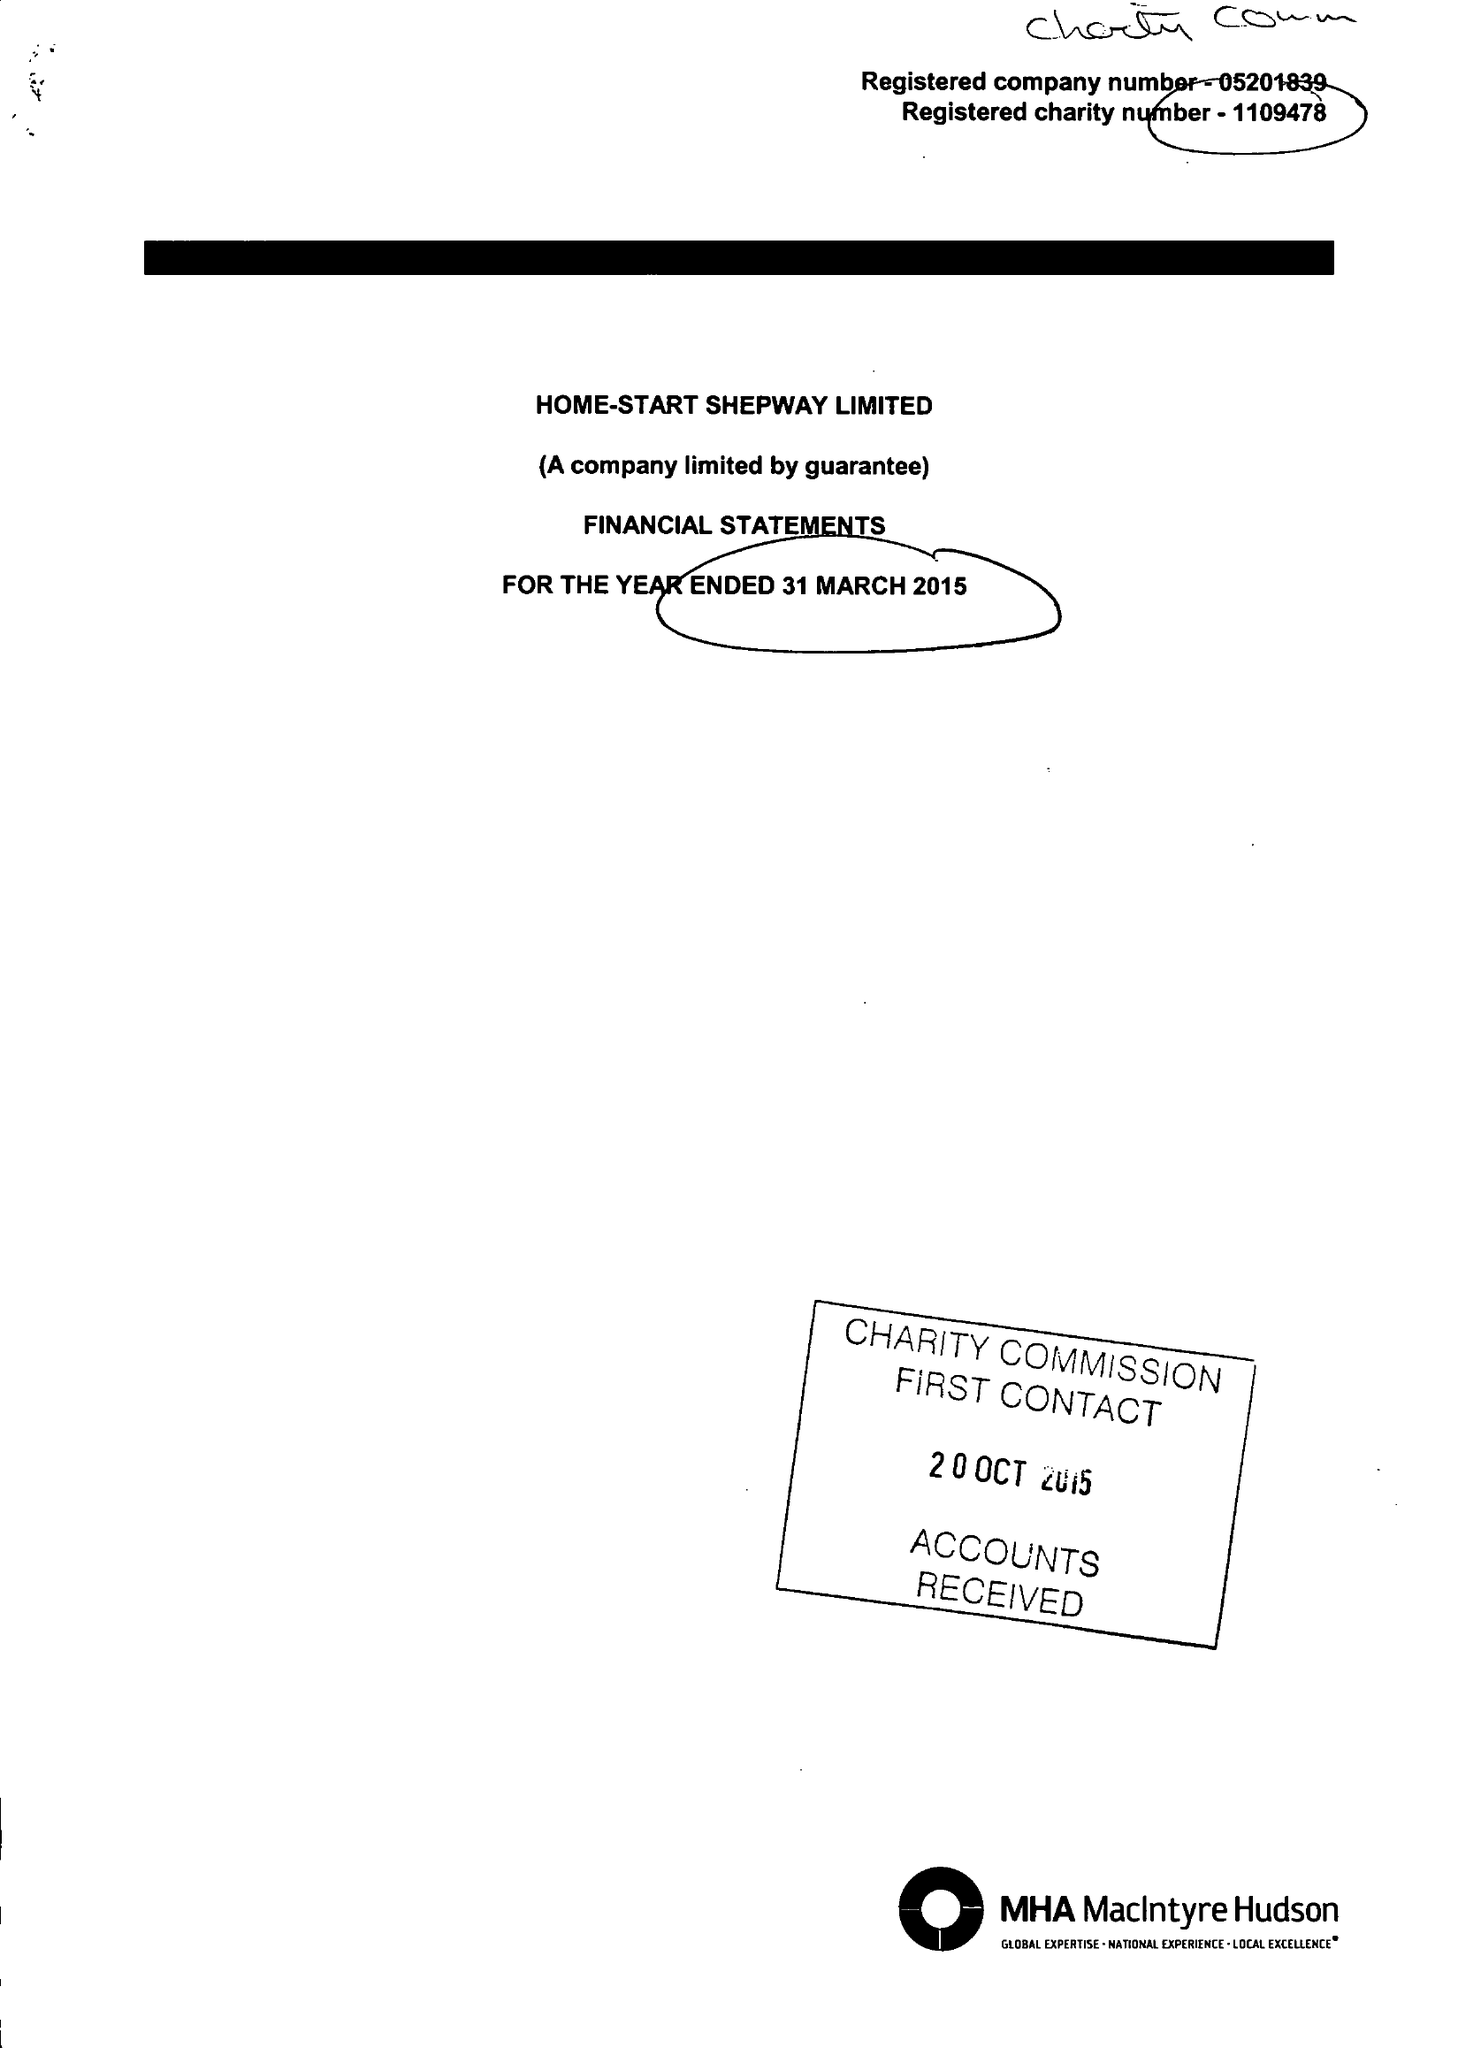What is the value for the address__street_line?
Answer the question using a single word or phrase. 24 CHERITON GARDENS 